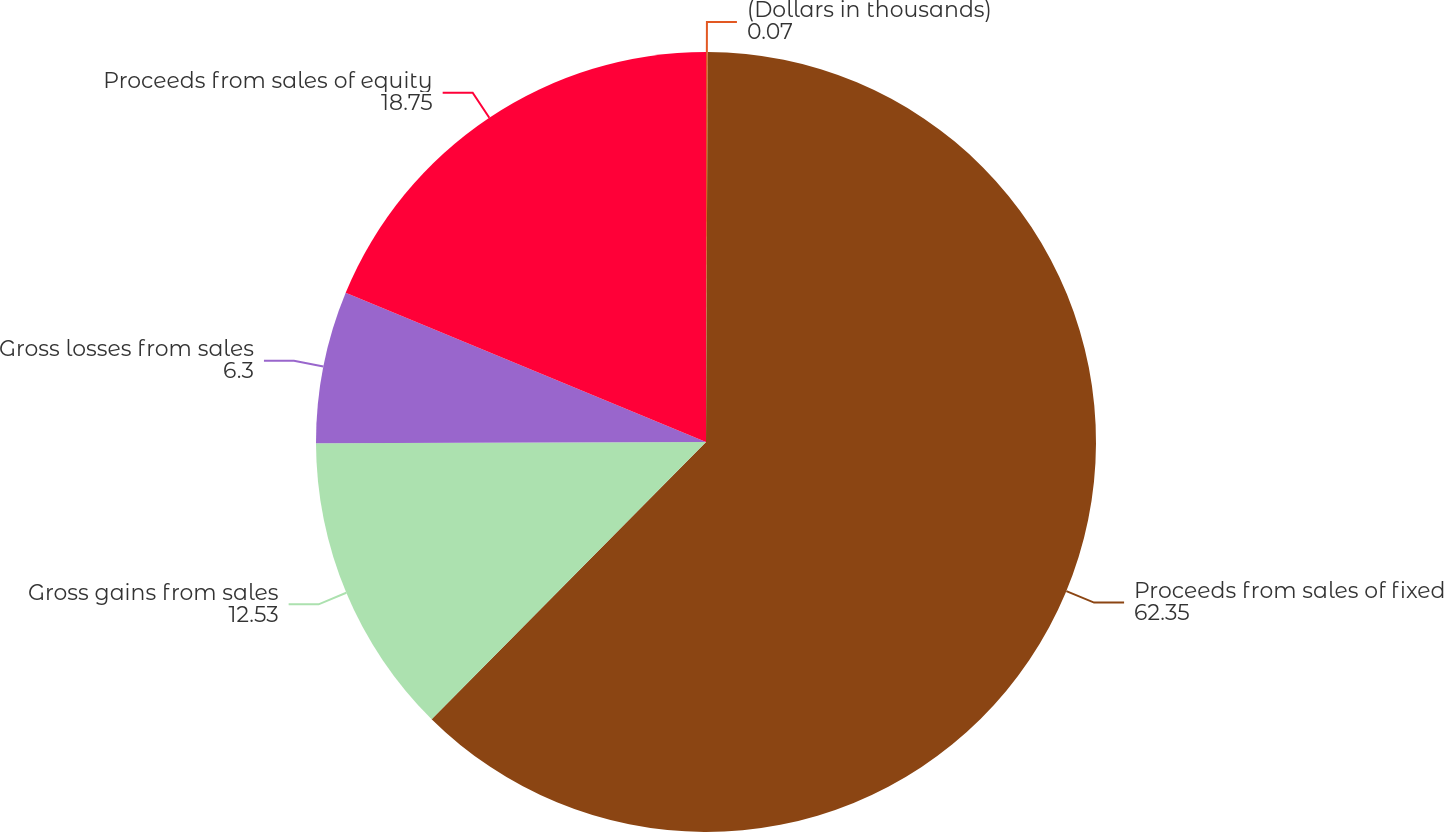Convert chart. <chart><loc_0><loc_0><loc_500><loc_500><pie_chart><fcel>(Dollars in thousands)<fcel>Proceeds from sales of fixed<fcel>Gross gains from sales<fcel>Gross losses from sales<fcel>Proceeds from sales of equity<nl><fcel>0.07%<fcel>62.35%<fcel>12.53%<fcel>6.3%<fcel>18.75%<nl></chart> 